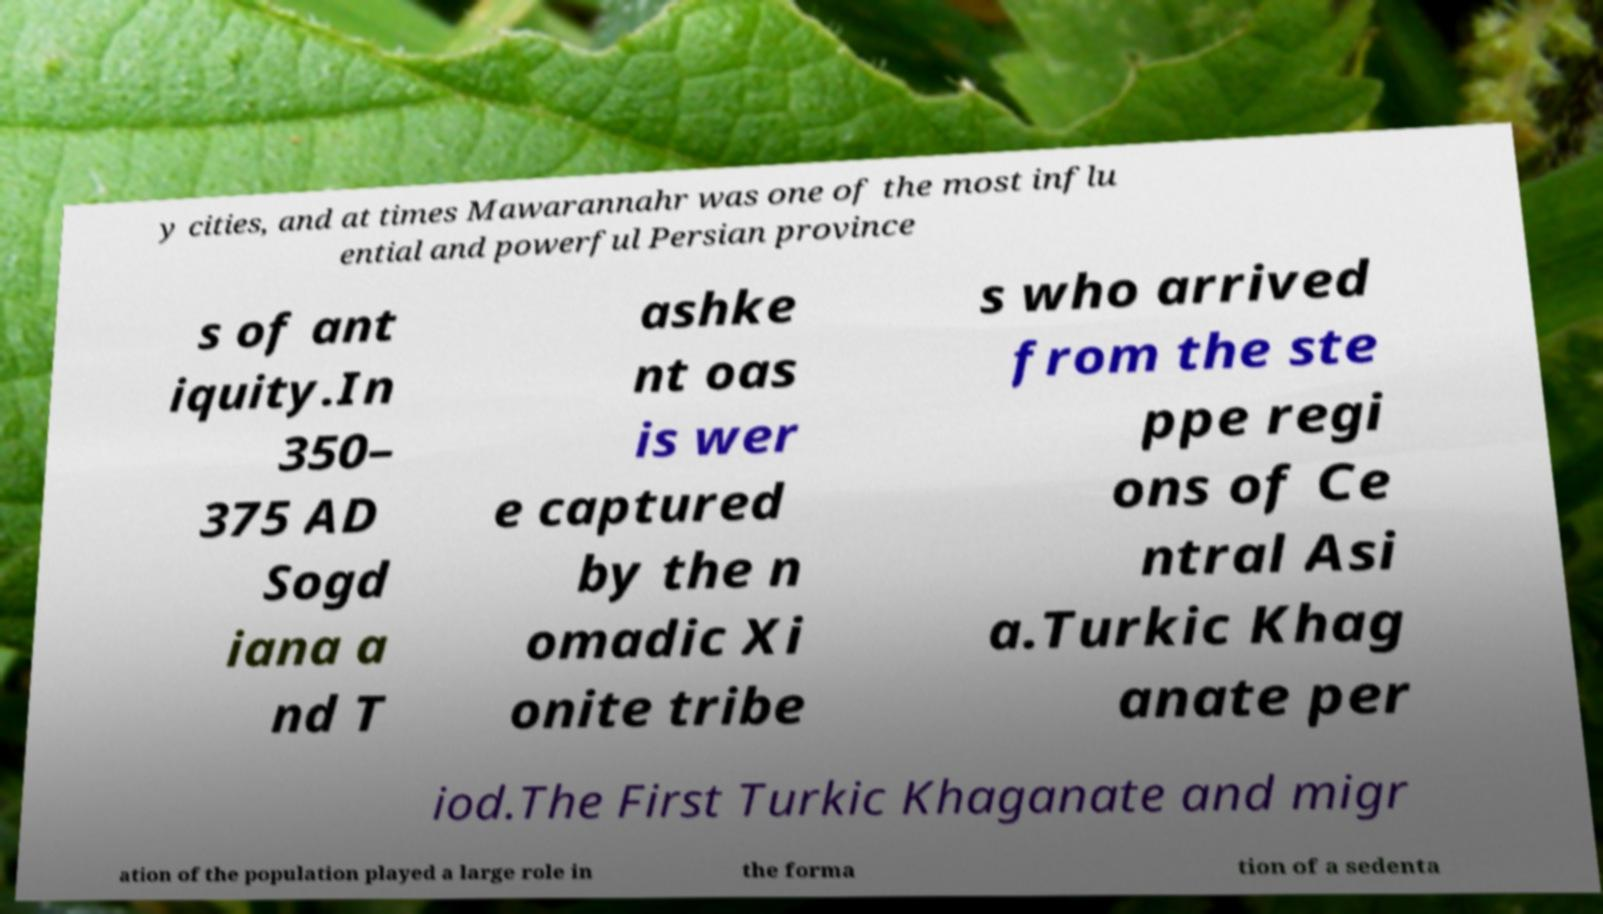Could you extract and type out the text from this image? y cities, and at times Mawarannahr was one of the most influ ential and powerful Persian province s of ant iquity.In 350– 375 AD Sogd iana a nd T ashke nt oas is wer e captured by the n omadic Xi onite tribe s who arrived from the ste ppe regi ons of Ce ntral Asi a.Turkic Khag anate per iod.The First Turkic Khaganate and migr ation of the population played a large role in the forma tion of a sedenta 